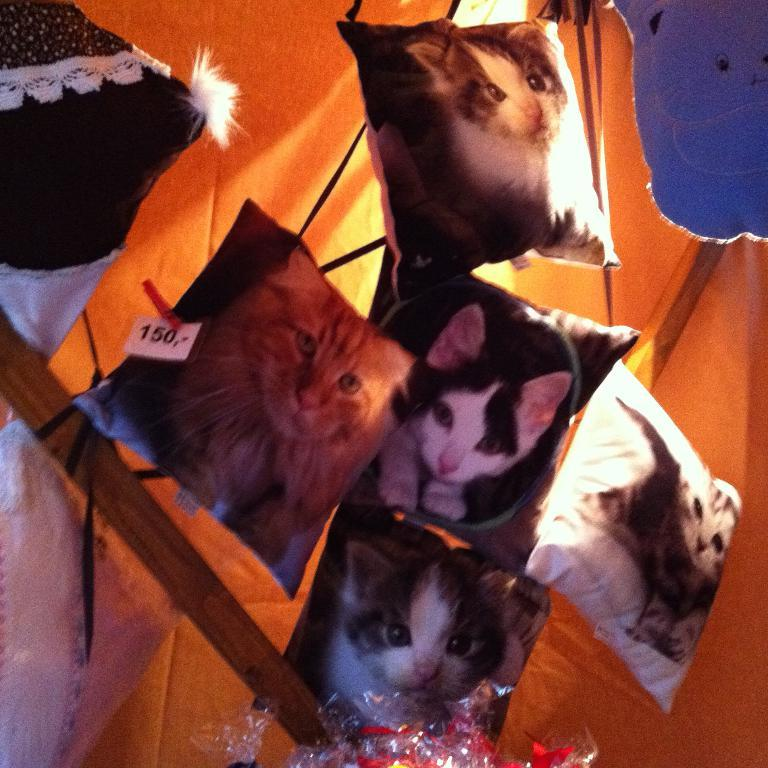What type of objects can be seen in the image? There are pillows in the image. What is depicted on the pillows? The pillows have cat pictures on them. What can be seen in the background of the image? There is a wooden stick and a tent in the background of the image. Where is the lunchroom located in the image? There is no lunchroom present in the image. How many balls are visible in the image? There are no balls visible in the image. 